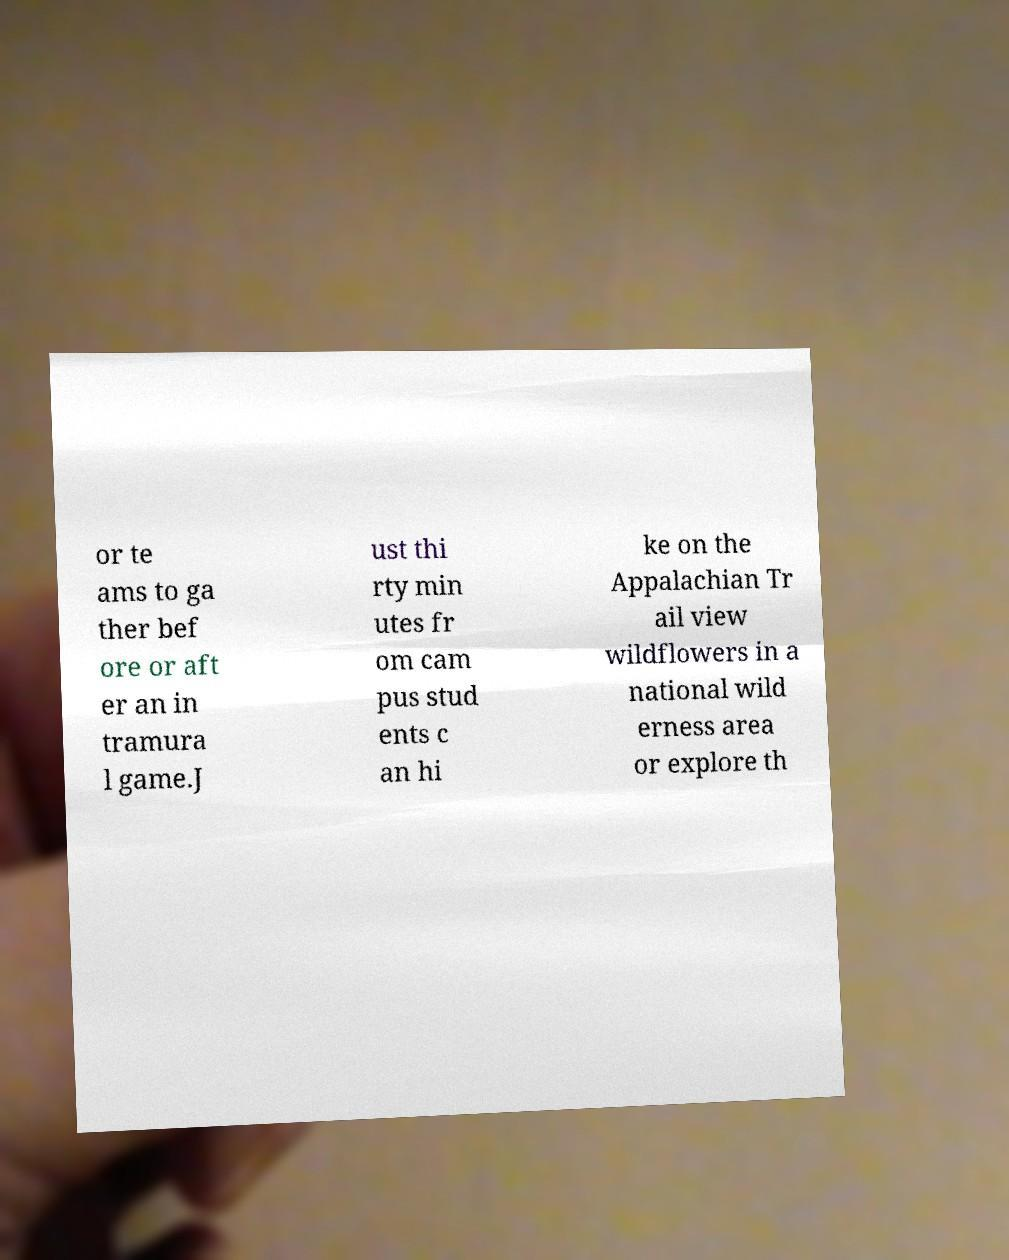Can you read and provide the text displayed in the image?This photo seems to have some interesting text. Can you extract and type it out for me? or te ams to ga ther bef ore or aft er an in tramura l game.J ust thi rty min utes fr om cam pus stud ents c an hi ke on the Appalachian Tr ail view wildflowers in a national wild erness area or explore th 